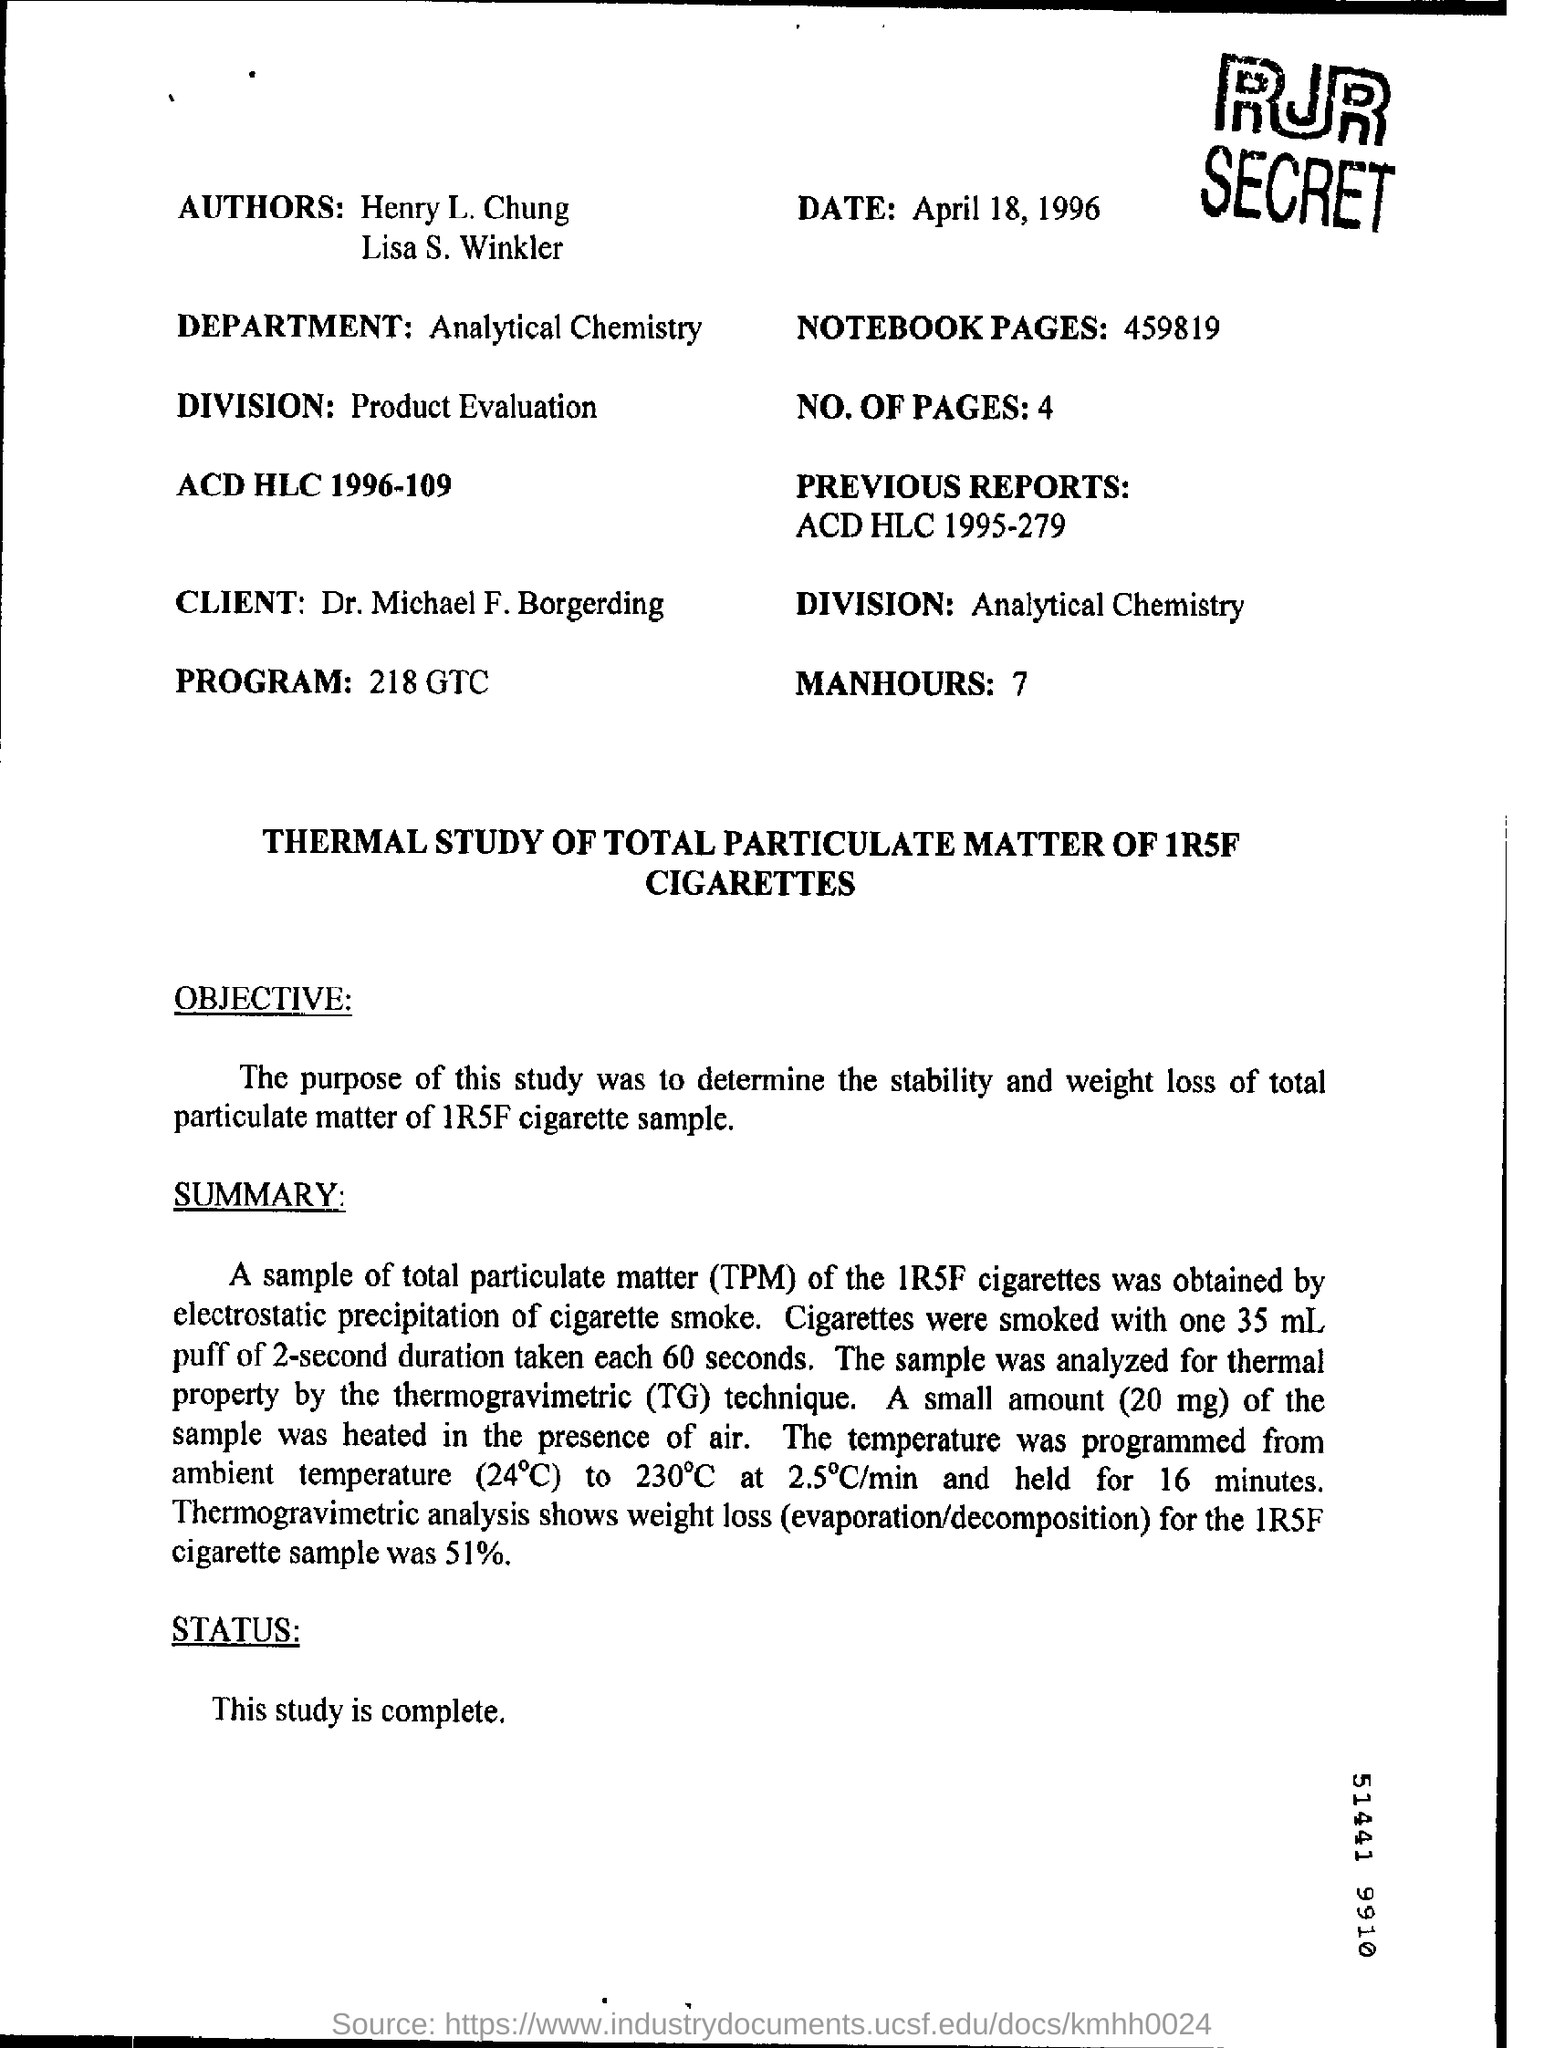What is the Date?
Provide a succinct answer. April 18, 1996. What are the Notebook Pages?
Offer a very short reply. 459819. What is the Department?
Offer a very short reply. Analytical chemistry. What is the "Division" of the client?
Offer a very short reply. Analytical chemistry. Who is the Client?
Give a very brief answer. Dr. Michael F. Borgerding. What is the name of the first person among the "authors"?
Keep it short and to the point. Henry L. Chung. What is the Status of this study?
Ensure brevity in your answer.  This study is complete. 